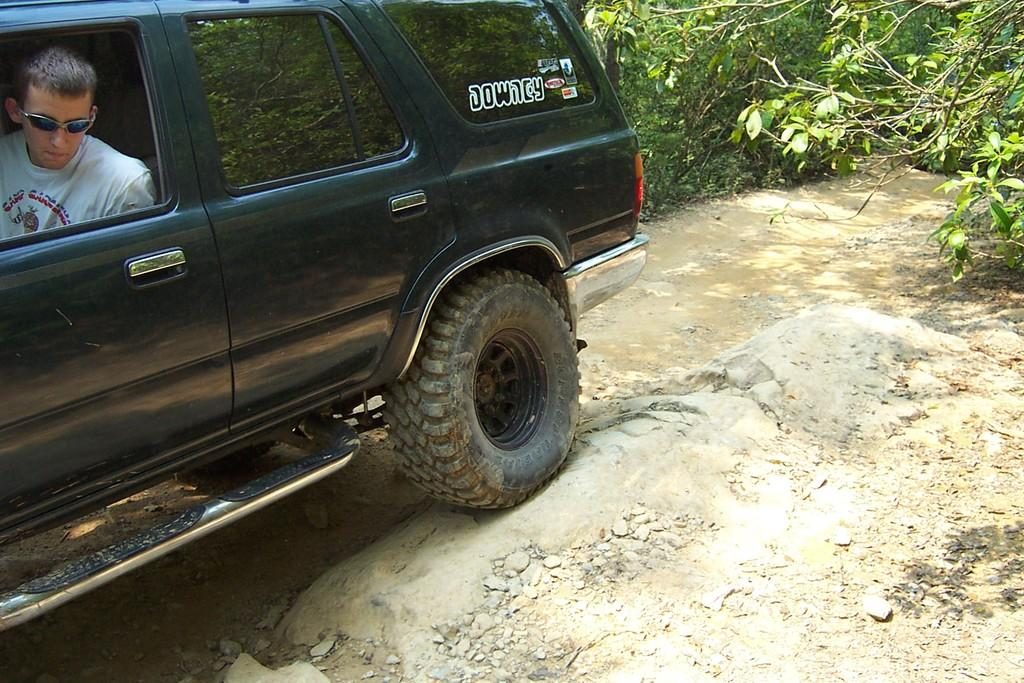What is the man in the image doing? The man is looking through the window of a vehicle. What color is the vehicle? The vehicle is black. What is the vehicle doing in the image? The vehicle is passing over a stone. How wide is the road in the image? The road is narrow. What can be seen on both sides of the road? There are plants on either side of the road. Is there a floor visible in the image? No, there is no floor visible in the image; it is focused on the man in the vehicle and the surrounding environment. 